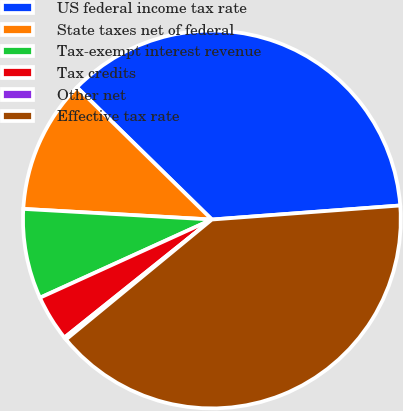Convert chart. <chart><loc_0><loc_0><loc_500><loc_500><pie_chart><fcel>US federal income tax rate<fcel>State taxes net of federal<fcel>Tax-exempt interest revenue<fcel>Tax credits<fcel>Other net<fcel>Effective tax rate<nl><fcel>36.48%<fcel>11.44%<fcel>7.69%<fcel>3.95%<fcel>0.21%<fcel>40.23%<nl></chart> 